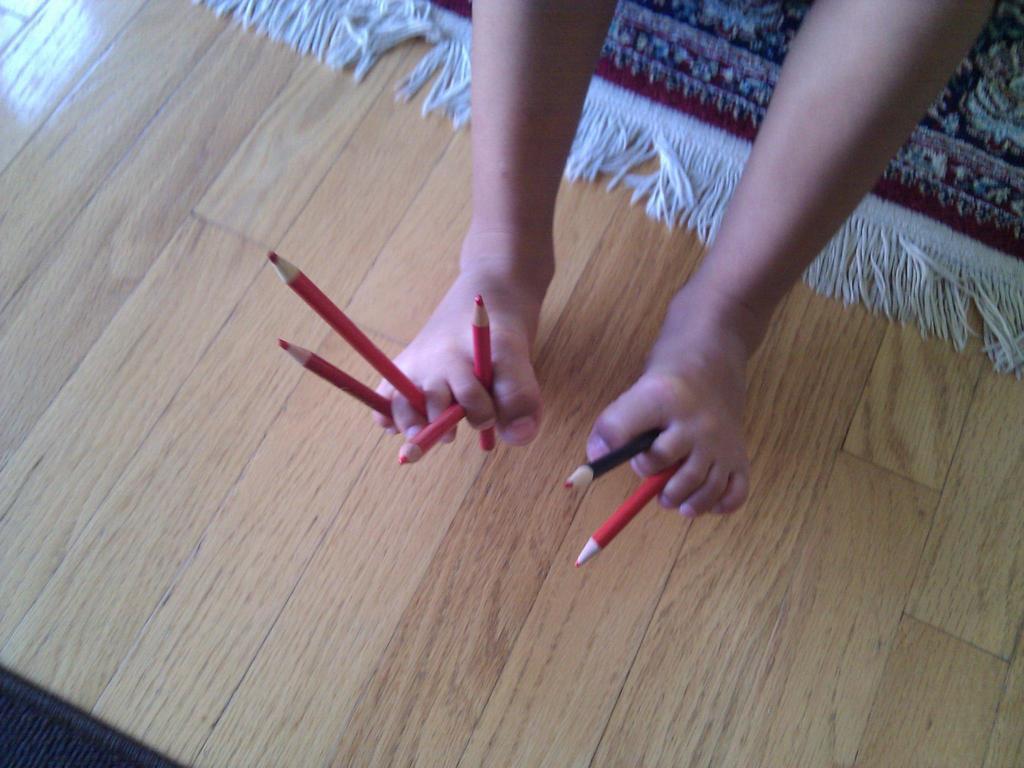Describe this image in one or two sentences. In this image I can see a person holding few pencils with legs. Background I can see a carpet in maroon color and the carpet is on the wooden board. 